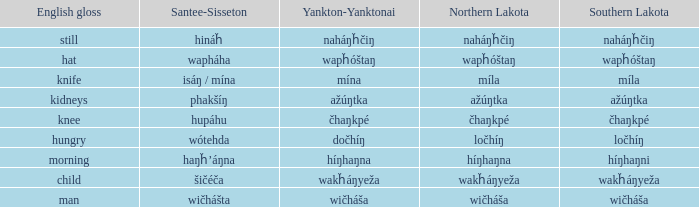Name the number of english gloss for wakȟáŋyeža 1.0. 